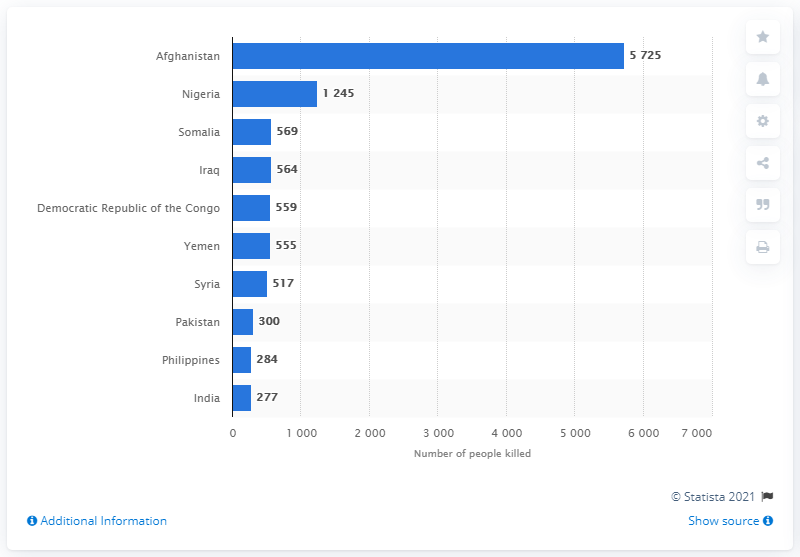List a handful of essential elements in this visual. Afghanistan was the country that was most heavily impacted by terrorism in 2019. According to recent statistics, Nigeria had the second highest number of deaths due to terrorism, following the country with the highest number of such deaths. 